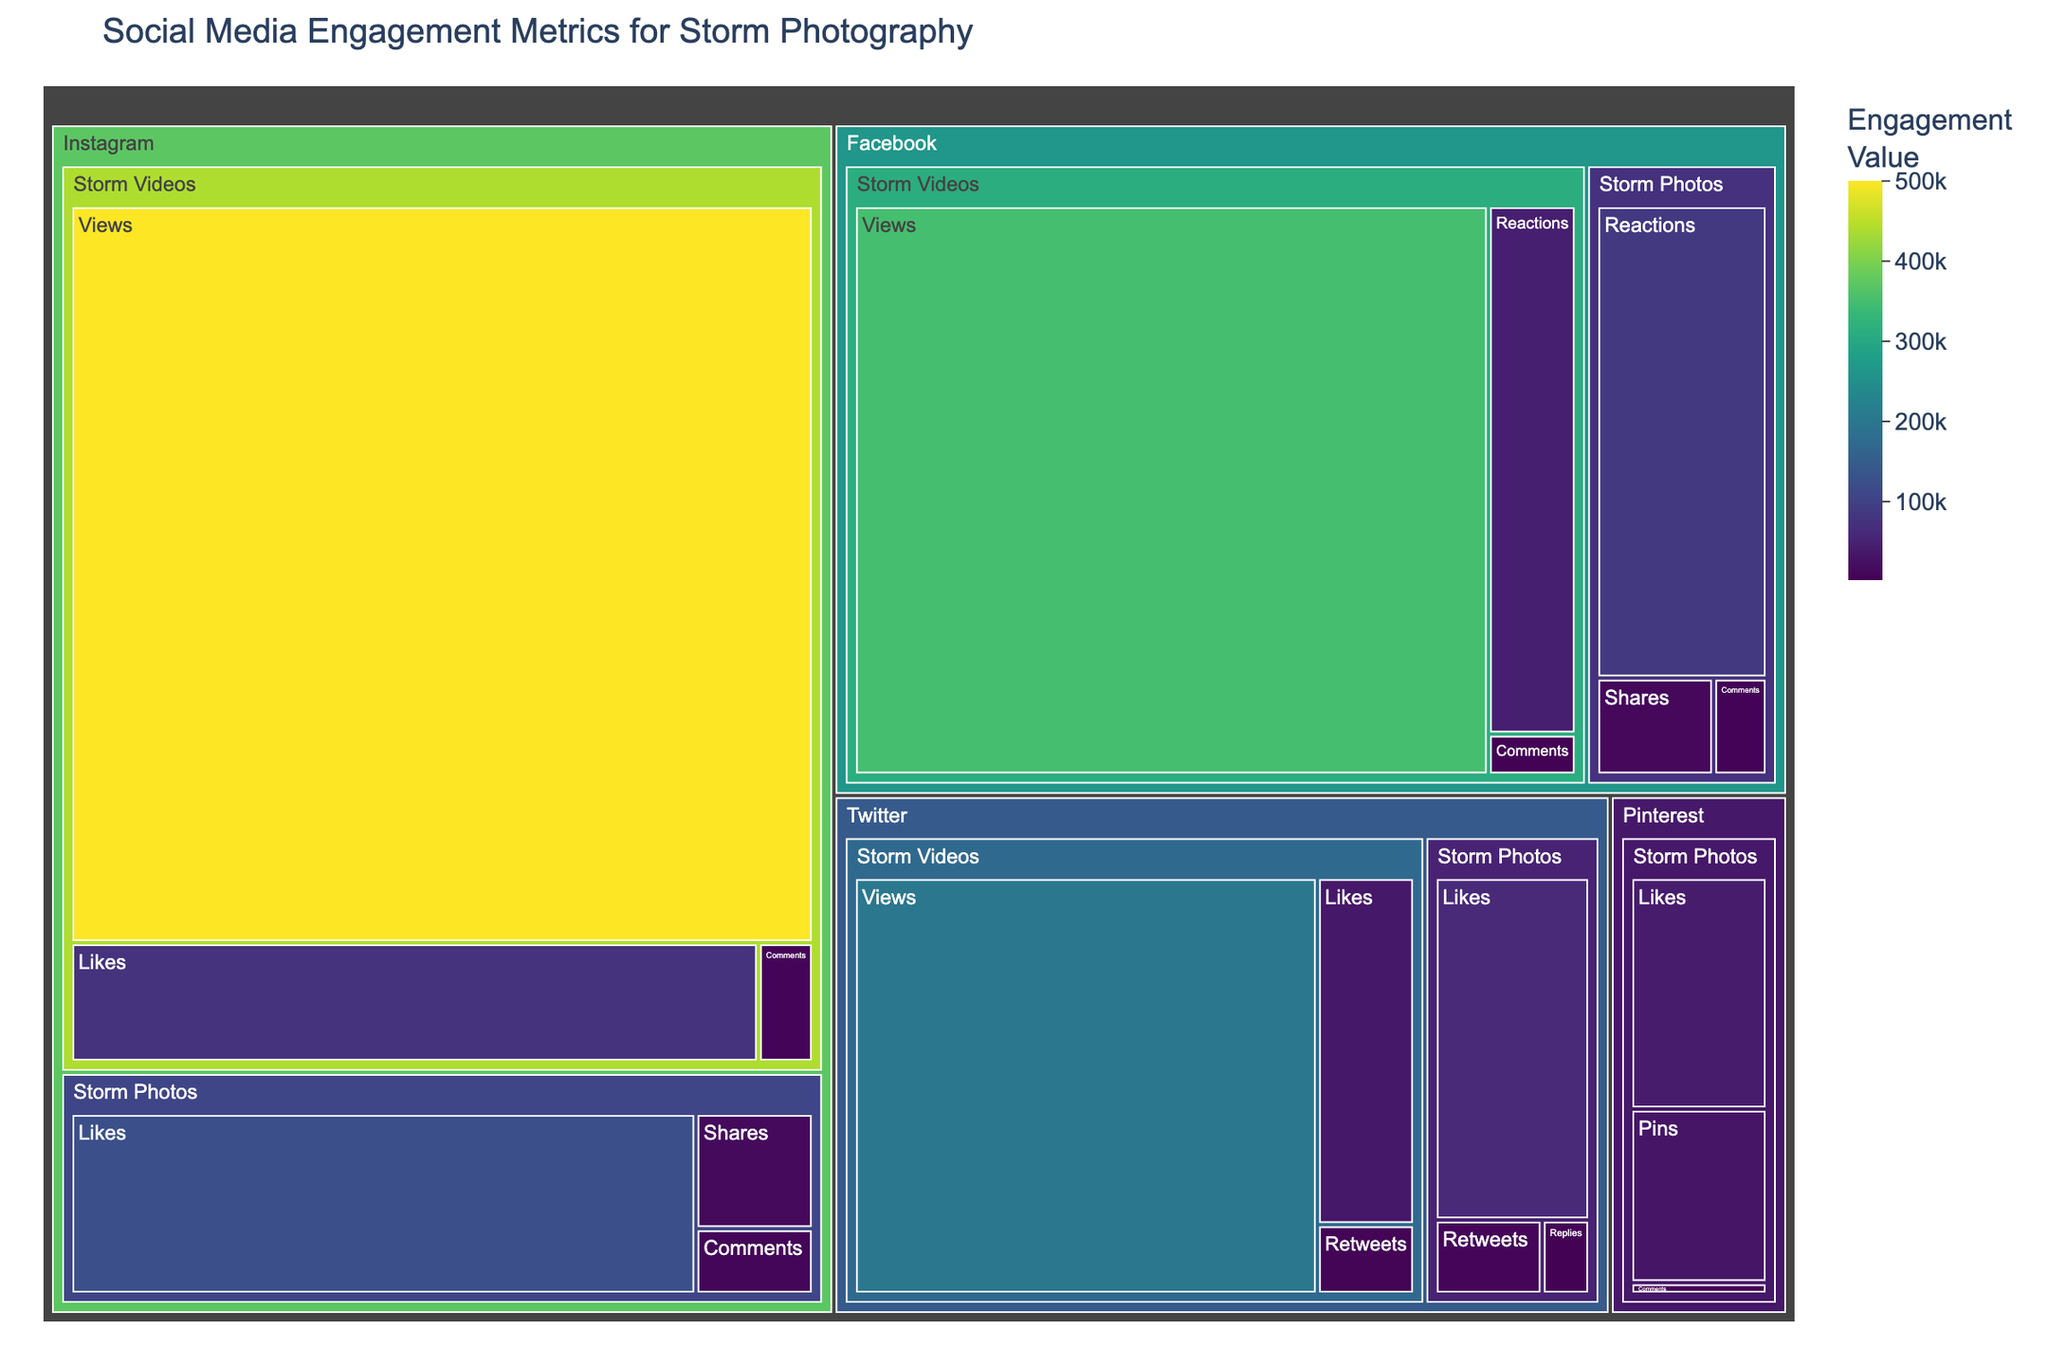What is the title of the figure? The title of the figure is displayed at the top of the Treemap.
Answer: Social Media Engagement Metrics for Storm Photography Which social media platform has the highest total engagement for Storm Photos? To find this, look at the sum of engagement metrics (likes, comments, shares, reactions, etc.) for Storm Photos on each platform. Instagram: 125000 (Likes) + 8500 (Comments) + 15000 (Shares) = 148500, Facebook: 85000 (Reactions) + 5500 (Comments) + 12000 (Shares) = 102500, Twitter: 60000 (Likes) + 9000 (Retweets) + 4000 (Replies) = 73000, Pinterest: 30000 (Pins) + 40000 (Likes) + 2000 (Comments) = 72000. Hence, Instagram has the highest total engagement.
Answer: Instagram Which platform and category combination has the highest single metric value? Look for the highest value among all metrics across platforms and categories. By scanning the figure, you can see Instagram Storm Videos Views with 500000 is the highest.
Answer: Instagram, Storm Videos How many different metrics are tracked for Instagram Storm Photos? By examining the number of distinct elements under the Instagram > Storm Photos category, we can count that there are three metrics: Likes, Comments, and Shares.
Answer: 3 What is the total number of views for Storm Videos across all platforms? Sum the views metrics for Storm Videos on all platforms: Instagram (500000) + Facebook (350000) + Twitter (200000) = 1050000.
Answer: 1050000 Which metric has a higher engagement value for Twitter Storm Videos: Likes or Retweets? Compare the values for Likes (35000) and Retweets (7000) for Twitter Storm Videos.
Answer: Likes What is the average number of views for Storm Videos on Instagram and Facebook? First, find the total number of views for both platforms and then calculate the average. Instagram: 500000, Facebook: 350000. Sum: 500000 + 350000 = 850000. Average: 850000 / 2 = 425000.
Answer: 425000 Which platform has the least engagement for Storm Photos in terms of comments or replies? Compare the comments or replies metrics for each platform under Storm Photos. Instagram: 8500, Facebook: 5500, Twitter: 4000, Pinterest: 2000. Pinterest has the least engagement with 2000 comments.
Answer: Pinterest Between Instagram and Facebook, which has a higher total engagement for Storm Videos considering all metrics? Sum all engagement metrics for Storm Videos on each platform. Instagram: 500000 (Views) + 75000 (Likes) + 6000 (Comments) = 581000, Facebook: 350000 (Views) + 45000 (Reactions) + 3500 (Comments) = 398500. Instagram has higher total engagement.
Answer: Instagram 